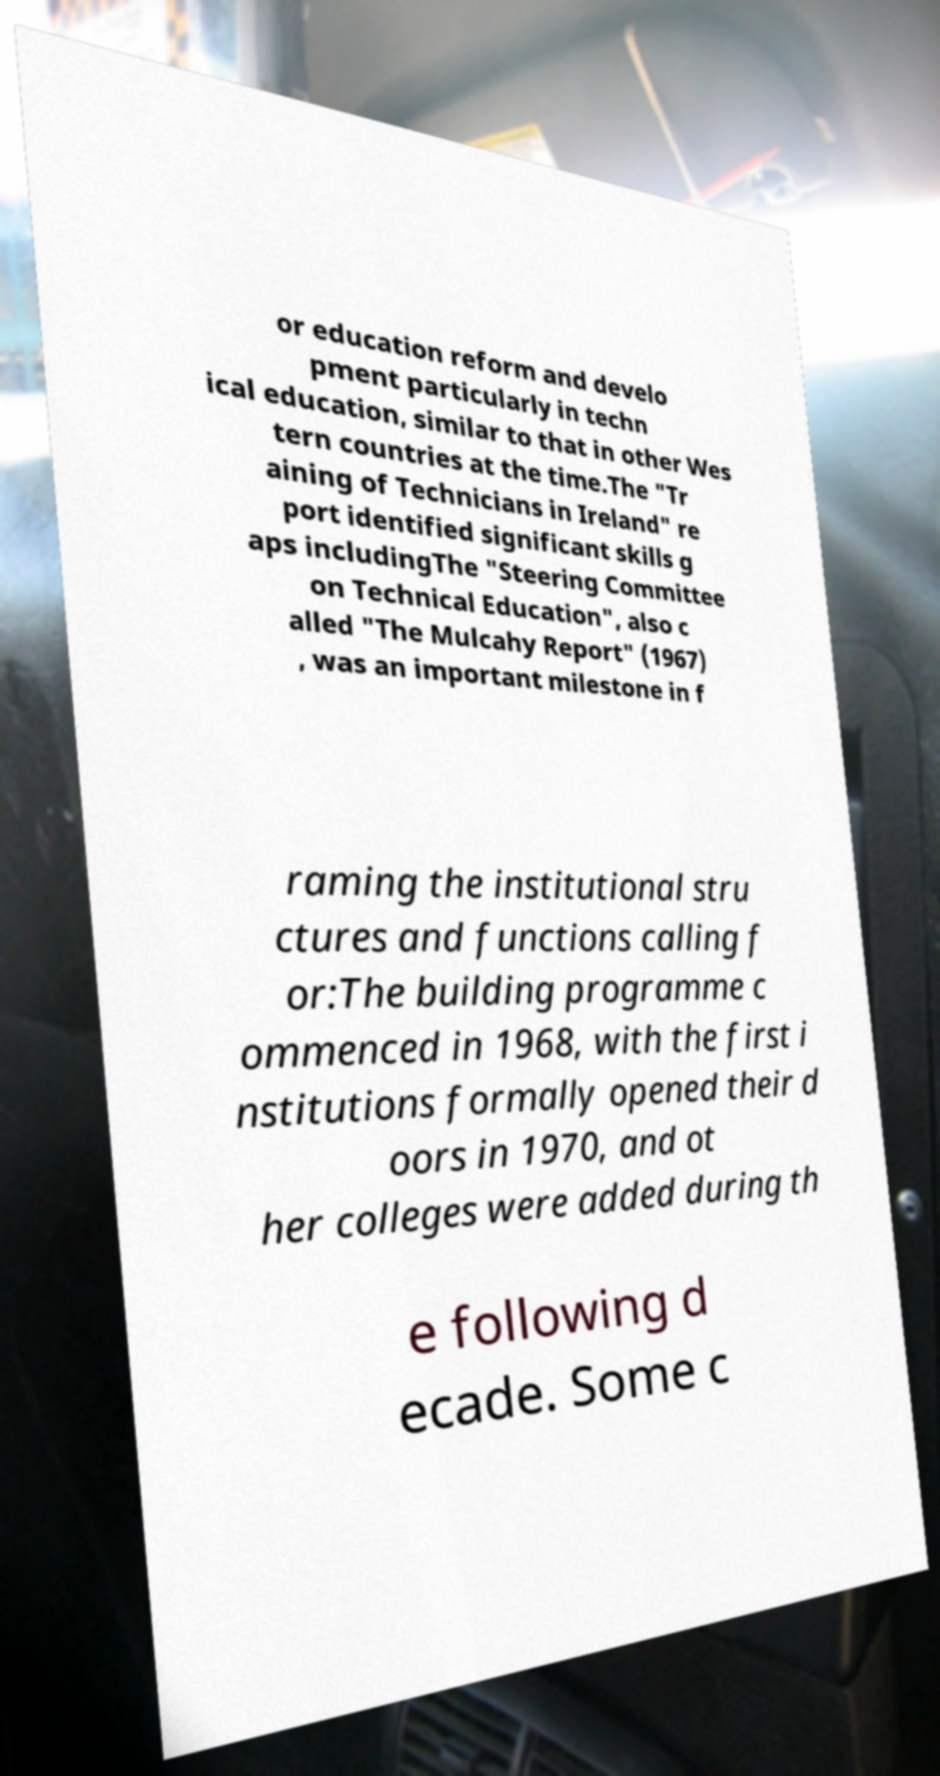Could you extract and type out the text from this image? or education reform and develo pment particularly in techn ical education, similar to that in other Wes tern countries at the time.The "Tr aining of Technicians in Ireland" re port identified significant skills g aps includingThe "Steering Committee on Technical Education", also c alled "The Mulcahy Report" (1967) , was an important milestone in f raming the institutional stru ctures and functions calling f or:The building programme c ommenced in 1968, with the first i nstitutions formally opened their d oors in 1970, and ot her colleges were added during th e following d ecade. Some c 